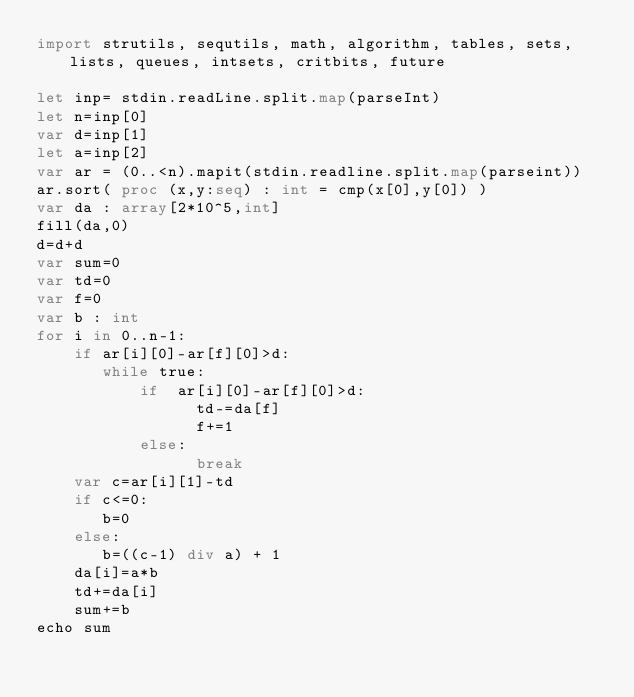Convert code to text. <code><loc_0><loc_0><loc_500><loc_500><_Nim_>import strutils, sequtils, math, algorithm, tables, sets, lists, queues, intsets, critbits, future

let inp= stdin.readLine.split.map(parseInt)
let n=inp[0]
var d=inp[1]
let a=inp[2]
var ar = (0..<n).mapit(stdin.readline.split.map(parseint))
ar.sort( proc (x,y:seq) : int = cmp(x[0],y[0]) )
var da : array[2*10^5,int]
fill(da,0)
d=d+d
var sum=0
var td=0
var f=0
var b : int
for i in 0..n-1:
    if ar[i][0]-ar[f][0]>d:
       while true: 
           if  ar[i][0]-ar[f][0]>d:
                 td-=da[f]
                 f+=1
           else:
                 break
    var c=ar[i][1]-td
    if c<=0:
       b=0
    else:
       b=((c-1) div a) + 1
    da[i]=a*b
    td+=da[i]
    sum+=b
echo sum
</code> 